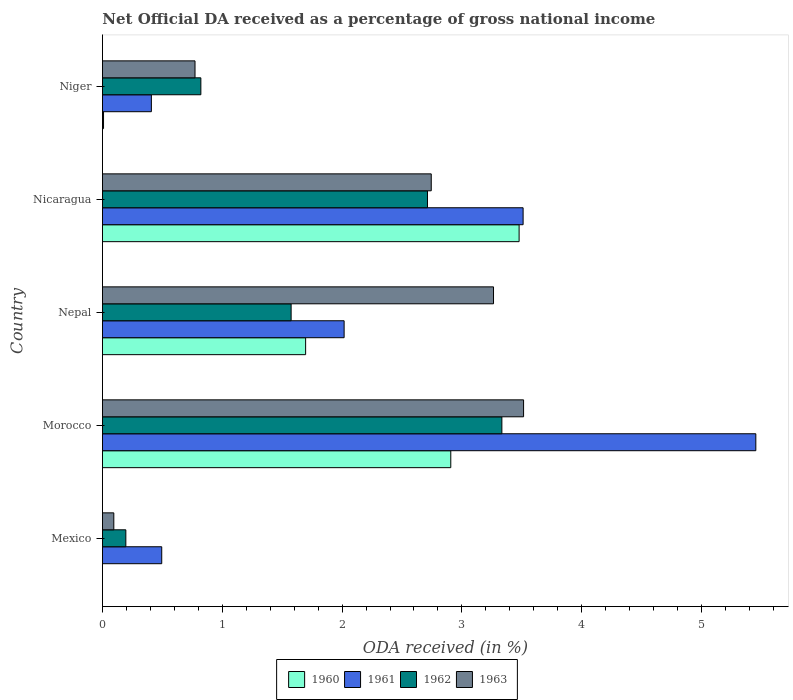How many groups of bars are there?
Give a very brief answer. 5. Are the number of bars on each tick of the Y-axis equal?
Give a very brief answer. No. What is the label of the 2nd group of bars from the top?
Keep it short and to the point. Nicaragua. In how many cases, is the number of bars for a given country not equal to the number of legend labels?
Your answer should be compact. 1. What is the net official DA received in 1962 in Nepal?
Keep it short and to the point. 1.57. Across all countries, what is the maximum net official DA received in 1960?
Keep it short and to the point. 3.48. Across all countries, what is the minimum net official DA received in 1963?
Make the answer very short. 0.09. In which country was the net official DA received in 1961 maximum?
Provide a succinct answer. Morocco. What is the total net official DA received in 1961 in the graph?
Offer a terse response. 11.88. What is the difference between the net official DA received in 1961 in Nepal and that in Nicaragua?
Provide a succinct answer. -1.49. What is the difference between the net official DA received in 1960 in Morocco and the net official DA received in 1962 in Nepal?
Offer a very short reply. 1.33. What is the average net official DA received in 1960 per country?
Your answer should be compact. 1.62. What is the difference between the net official DA received in 1963 and net official DA received in 1961 in Nepal?
Make the answer very short. 1.25. In how many countries, is the net official DA received in 1961 greater than 4.4 %?
Offer a very short reply. 1. What is the ratio of the net official DA received in 1963 in Nepal to that in Niger?
Make the answer very short. 4.23. Is the difference between the net official DA received in 1963 in Mexico and Niger greater than the difference between the net official DA received in 1961 in Mexico and Niger?
Your answer should be very brief. No. What is the difference between the highest and the second highest net official DA received in 1962?
Your response must be concise. 0.62. What is the difference between the highest and the lowest net official DA received in 1960?
Keep it short and to the point. 3.48. Are all the bars in the graph horizontal?
Ensure brevity in your answer.  Yes. How many countries are there in the graph?
Provide a short and direct response. 5. Where does the legend appear in the graph?
Your answer should be very brief. Bottom center. What is the title of the graph?
Keep it short and to the point. Net Official DA received as a percentage of gross national income. What is the label or title of the X-axis?
Offer a terse response. ODA received (in %). What is the ODA received (in %) of 1961 in Mexico?
Keep it short and to the point. 0.49. What is the ODA received (in %) in 1962 in Mexico?
Your response must be concise. 0.2. What is the ODA received (in %) of 1963 in Mexico?
Your answer should be very brief. 0.09. What is the ODA received (in %) of 1960 in Morocco?
Ensure brevity in your answer.  2.91. What is the ODA received (in %) of 1961 in Morocco?
Provide a succinct answer. 5.45. What is the ODA received (in %) of 1962 in Morocco?
Give a very brief answer. 3.33. What is the ODA received (in %) of 1963 in Morocco?
Offer a very short reply. 3.51. What is the ODA received (in %) of 1960 in Nepal?
Give a very brief answer. 1.7. What is the ODA received (in %) in 1961 in Nepal?
Provide a succinct answer. 2.02. What is the ODA received (in %) of 1962 in Nepal?
Give a very brief answer. 1.57. What is the ODA received (in %) in 1963 in Nepal?
Keep it short and to the point. 3.26. What is the ODA received (in %) in 1960 in Nicaragua?
Ensure brevity in your answer.  3.48. What is the ODA received (in %) of 1961 in Nicaragua?
Keep it short and to the point. 3.51. What is the ODA received (in %) of 1962 in Nicaragua?
Ensure brevity in your answer.  2.71. What is the ODA received (in %) in 1963 in Nicaragua?
Your answer should be very brief. 2.74. What is the ODA received (in %) of 1960 in Niger?
Your response must be concise. 0.01. What is the ODA received (in %) of 1961 in Niger?
Your answer should be compact. 0.41. What is the ODA received (in %) of 1962 in Niger?
Offer a terse response. 0.82. What is the ODA received (in %) of 1963 in Niger?
Offer a terse response. 0.77. Across all countries, what is the maximum ODA received (in %) of 1960?
Ensure brevity in your answer.  3.48. Across all countries, what is the maximum ODA received (in %) in 1961?
Your answer should be very brief. 5.45. Across all countries, what is the maximum ODA received (in %) in 1962?
Keep it short and to the point. 3.33. Across all countries, what is the maximum ODA received (in %) of 1963?
Keep it short and to the point. 3.51. Across all countries, what is the minimum ODA received (in %) in 1961?
Ensure brevity in your answer.  0.41. Across all countries, what is the minimum ODA received (in %) of 1962?
Your answer should be compact. 0.2. Across all countries, what is the minimum ODA received (in %) in 1963?
Keep it short and to the point. 0.09. What is the total ODA received (in %) of 1960 in the graph?
Provide a short and direct response. 8.09. What is the total ODA received (in %) in 1961 in the graph?
Provide a short and direct response. 11.88. What is the total ODA received (in %) of 1962 in the graph?
Your answer should be very brief. 8.64. What is the total ODA received (in %) of 1963 in the graph?
Your response must be concise. 10.39. What is the difference between the ODA received (in %) of 1961 in Mexico and that in Morocco?
Make the answer very short. -4.96. What is the difference between the ODA received (in %) of 1962 in Mexico and that in Morocco?
Ensure brevity in your answer.  -3.14. What is the difference between the ODA received (in %) in 1963 in Mexico and that in Morocco?
Your answer should be compact. -3.42. What is the difference between the ODA received (in %) of 1961 in Mexico and that in Nepal?
Your answer should be very brief. -1.52. What is the difference between the ODA received (in %) of 1962 in Mexico and that in Nepal?
Your answer should be compact. -1.38. What is the difference between the ODA received (in %) of 1963 in Mexico and that in Nepal?
Give a very brief answer. -3.17. What is the difference between the ODA received (in %) in 1961 in Mexico and that in Nicaragua?
Provide a succinct answer. -3.02. What is the difference between the ODA received (in %) in 1962 in Mexico and that in Nicaragua?
Give a very brief answer. -2.52. What is the difference between the ODA received (in %) in 1963 in Mexico and that in Nicaragua?
Your response must be concise. -2.65. What is the difference between the ODA received (in %) of 1961 in Mexico and that in Niger?
Provide a short and direct response. 0.09. What is the difference between the ODA received (in %) of 1962 in Mexico and that in Niger?
Offer a terse response. -0.63. What is the difference between the ODA received (in %) in 1963 in Mexico and that in Niger?
Provide a succinct answer. -0.68. What is the difference between the ODA received (in %) in 1960 in Morocco and that in Nepal?
Provide a short and direct response. 1.21. What is the difference between the ODA received (in %) of 1961 in Morocco and that in Nepal?
Your answer should be compact. 3.44. What is the difference between the ODA received (in %) in 1962 in Morocco and that in Nepal?
Give a very brief answer. 1.76. What is the difference between the ODA received (in %) of 1963 in Morocco and that in Nepal?
Provide a succinct answer. 0.25. What is the difference between the ODA received (in %) in 1960 in Morocco and that in Nicaragua?
Provide a succinct answer. -0.57. What is the difference between the ODA received (in %) in 1961 in Morocco and that in Nicaragua?
Offer a terse response. 1.94. What is the difference between the ODA received (in %) in 1962 in Morocco and that in Nicaragua?
Offer a terse response. 0.62. What is the difference between the ODA received (in %) of 1963 in Morocco and that in Nicaragua?
Your response must be concise. 0.77. What is the difference between the ODA received (in %) in 1960 in Morocco and that in Niger?
Your response must be concise. 2.9. What is the difference between the ODA received (in %) in 1961 in Morocco and that in Niger?
Give a very brief answer. 5.05. What is the difference between the ODA received (in %) in 1962 in Morocco and that in Niger?
Provide a succinct answer. 2.51. What is the difference between the ODA received (in %) of 1963 in Morocco and that in Niger?
Offer a very short reply. 2.74. What is the difference between the ODA received (in %) in 1960 in Nepal and that in Nicaragua?
Provide a succinct answer. -1.78. What is the difference between the ODA received (in %) in 1961 in Nepal and that in Nicaragua?
Make the answer very short. -1.49. What is the difference between the ODA received (in %) in 1962 in Nepal and that in Nicaragua?
Make the answer very short. -1.14. What is the difference between the ODA received (in %) of 1963 in Nepal and that in Nicaragua?
Make the answer very short. 0.52. What is the difference between the ODA received (in %) of 1960 in Nepal and that in Niger?
Offer a very short reply. 1.69. What is the difference between the ODA received (in %) in 1961 in Nepal and that in Niger?
Give a very brief answer. 1.61. What is the difference between the ODA received (in %) of 1962 in Nepal and that in Niger?
Offer a terse response. 0.75. What is the difference between the ODA received (in %) of 1963 in Nepal and that in Niger?
Your response must be concise. 2.49. What is the difference between the ODA received (in %) of 1960 in Nicaragua and that in Niger?
Your answer should be very brief. 3.47. What is the difference between the ODA received (in %) of 1961 in Nicaragua and that in Niger?
Provide a short and direct response. 3.1. What is the difference between the ODA received (in %) in 1962 in Nicaragua and that in Niger?
Make the answer very short. 1.89. What is the difference between the ODA received (in %) in 1963 in Nicaragua and that in Niger?
Offer a terse response. 1.97. What is the difference between the ODA received (in %) in 1961 in Mexico and the ODA received (in %) in 1962 in Morocco?
Give a very brief answer. -2.84. What is the difference between the ODA received (in %) in 1961 in Mexico and the ODA received (in %) in 1963 in Morocco?
Provide a succinct answer. -3.02. What is the difference between the ODA received (in %) in 1962 in Mexico and the ODA received (in %) in 1963 in Morocco?
Keep it short and to the point. -3.32. What is the difference between the ODA received (in %) in 1961 in Mexico and the ODA received (in %) in 1962 in Nepal?
Make the answer very short. -1.08. What is the difference between the ODA received (in %) of 1961 in Mexico and the ODA received (in %) of 1963 in Nepal?
Offer a very short reply. -2.77. What is the difference between the ODA received (in %) of 1962 in Mexico and the ODA received (in %) of 1963 in Nepal?
Offer a terse response. -3.07. What is the difference between the ODA received (in %) of 1961 in Mexico and the ODA received (in %) of 1962 in Nicaragua?
Your answer should be compact. -2.22. What is the difference between the ODA received (in %) in 1961 in Mexico and the ODA received (in %) in 1963 in Nicaragua?
Provide a short and direct response. -2.25. What is the difference between the ODA received (in %) of 1962 in Mexico and the ODA received (in %) of 1963 in Nicaragua?
Make the answer very short. -2.55. What is the difference between the ODA received (in %) in 1961 in Mexico and the ODA received (in %) in 1962 in Niger?
Your response must be concise. -0.33. What is the difference between the ODA received (in %) in 1961 in Mexico and the ODA received (in %) in 1963 in Niger?
Your answer should be compact. -0.28. What is the difference between the ODA received (in %) of 1962 in Mexico and the ODA received (in %) of 1963 in Niger?
Offer a terse response. -0.58. What is the difference between the ODA received (in %) of 1960 in Morocco and the ODA received (in %) of 1961 in Nepal?
Keep it short and to the point. 0.89. What is the difference between the ODA received (in %) of 1960 in Morocco and the ODA received (in %) of 1962 in Nepal?
Your answer should be compact. 1.33. What is the difference between the ODA received (in %) of 1960 in Morocco and the ODA received (in %) of 1963 in Nepal?
Make the answer very short. -0.36. What is the difference between the ODA received (in %) in 1961 in Morocco and the ODA received (in %) in 1962 in Nepal?
Ensure brevity in your answer.  3.88. What is the difference between the ODA received (in %) in 1961 in Morocco and the ODA received (in %) in 1963 in Nepal?
Your answer should be compact. 2.19. What is the difference between the ODA received (in %) of 1962 in Morocco and the ODA received (in %) of 1963 in Nepal?
Offer a very short reply. 0.07. What is the difference between the ODA received (in %) of 1960 in Morocco and the ODA received (in %) of 1961 in Nicaragua?
Your response must be concise. -0.6. What is the difference between the ODA received (in %) of 1960 in Morocco and the ODA received (in %) of 1962 in Nicaragua?
Your answer should be very brief. 0.19. What is the difference between the ODA received (in %) in 1960 in Morocco and the ODA received (in %) in 1963 in Nicaragua?
Offer a very short reply. 0.16. What is the difference between the ODA received (in %) of 1961 in Morocco and the ODA received (in %) of 1962 in Nicaragua?
Your response must be concise. 2.74. What is the difference between the ODA received (in %) in 1961 in Morocco and the ODA received (in %) in 1963 in Nicaragua?
Your answer should be compact. 2.71. What is the difference between the ODA received (in %) of 1962 in Morocco and the ODA received (in %) of 1963 in Nicaragua?
Provide a succinct answer. 0.59. What is the difference between the ODA received (in %) of 1960 in Morocco and the ODA received (in %) of 1961 in Niger?
Make the answer very short. 2.5. What is the difference between the ODA received (in %) in 1960 in Morocco and the ODA received (in %) in 1962 in Niger?
Ensure brevity in your answer.  2.09. What is the difference between the ODA received (in %) in 1960 in Morocco and the ODA received (in %) in 1963 in Niger?
Offer a terse response. 2.13. What is the difference between the ODA received (in %) of 1961 in Morocco and the ODA received (in %) of 1962 in Niger?
Your response must be concise. 4.63. What is the difference between the ODA received (in %) in 1961 in Morocco and the ODA received (in %) in 1963 in Niger?
Offer a very short reply. 4.68. What is the difference between the ODA received (in %) in 1962 in Morocco and the ODA received (in %) in 1963 in Niger?
Provide a short and direct response. 2.56. What is the difference between the ODA received (in %) in 1960 in Nepal and the ODA received (in %) in 1961 in Nicaragua?
Give a very brief answer. -1.82. What is the difference between the ODA received (in %) of 1960 in Nepal and the ODA received (in %) of 1962 in Nicaragua?
Provide a succinct answer. -1.02. What is the difference between the ODA received (in %) of 1960 in Nepal and the ODA received (in %) of 1963 in Nicaragua?
Provide a succinct answer. -1.05. What is the difference between the ODA received (in %) in 1961 in Nepal and the ODA received (in %) in 1962 in Nicaragua?
Your response must be concise. -0.7. What is the difference between the ODA received (in %) of 1961 in Nepal and the ODA received (in %) of 1963 in Nicaragua?
Offer a terse response. -0.73. What is the difference between the ODA received (in %) of 1962 in Nepal and the ODA received (in %) of 1963 in Nicaragua?
Give a very brief answer. -1.17. What is the difference between the ODA received (in %) in 1960 in Nepal and the ODA received (in %) in 1961 in Niger?
Give a very brief answer. 1.29. What is the difference between the ODA received (in %) of 1960 in Nepal and the ODA received (in %) of 1962 in Niger?
Keep it short and to the point. 0.87. What is the difference between the ODA received (in %) in 1960 in Nepal and the ODA received (in %) in 1963 in Niger?
Give a very brief answer. 0.92. What is the difference between the ODA received (in %) in 1961 in Nepal and the ODA received (in %) in 1962 in Niger?
Give a very brief answer. 1.2. What is the difference between the ODA received (in %) of 1961 in Nepal and the ODA received (in %) of 1963 in Niger?
Your answer should be compact. 1.24. What is the difference between the ODA received (in %) in 1962 in Nepal and the ODA received (in %) in 1963 in Niger?
Provide a short and direct response. 0.8. What is the difference between the ODA received (in %) in 1960 in Nicaragua and the ODA received (in %) in 1961 in Niger?
Ensure brevity in your answer.  3.07. What is the difference between the ODA received (in %) of 1960 in Nicaragua and the ODA received (in %) of 1962 in Niger?
Provide a succinct answer. 2.66. What is the difference between the ODA received (in %) of 1960 in Nicaragua and the ODA received (in %) of 1963 in Niger?
Provide a short and direct response. 2.71. What is the difference between the ODA received (in %) of 1961 in Nicaragua and the ODA received (in %) of 1962 in Niger?
Keep it short and to the point. 2.69. What is the difference between the ODA received (in %) of 1961 in Nicaragua and the ODA received (in %) of 1963 in Niger?
Provide a succinct answer. 2.74. What is the difference between the ODA received (in %) of 1962 in Nicaragua and the ODA received (in %) of 1963 in Niger?
Offer a very short reply. 1.94. What is the average ODA received (in %) in 1960 per country?
Your response must be concise. 1.62. What is the average ODA received (in %) of 1961 per country?
Provide a short and direct response. 2.38. What is the average ODA received (in %) in 1962 per country?
Your answer should be compact. 1.73. What is the average ODA received (in %) of 1963 per country?
Provide a succinct answer. 2.08. What is the difference between the ODA received (in %) in 1961 and ODA received (in %) in 1962 in Mexico?
Provide a short and direct response. 0.3. What is the difference between the ODA received (in %) in 1962 and ODA received (in %) in 1963 in Mexico?
Make the answer very short. 0.1. What is the difference between the ODA received (in %) of 1960 and ODA received (in %) of 1961 in Morocco?
Offer a very short reply. -2.55. What is the difference between the ODA received (in %) of 1960 and ODA received (in %) of 1962 in Morocco?
Ensure brevity in your answer.  -0.43. What is the difference between the ODA received (in %) of 1960 and ODA received (in %) of 1963 in Morocco?
Your answer should be very brief. -0.61. What is the difference between the ODA received (in %) of 1961 and ODA received (in %) of 1962 in Morocco?
Make the answer very short. 2.12. What is the difference between the ODA received (in %) in 1961 and ODA received (in %) in 1963 in Morocco?
Offer a very short reply. 1.94. What is the difference between the ODA received (in %) of 1962 and ODA received (in %) of 1963 in Morocco?
Your answer should be very brief. -0.18. What is the difference between the ODA received (in %) in 1960 and ODA received (in %) in 1961 in Nepal?
Make the answer very short. -0.32. What is the difference between the ODA received (in %) of 1960 and ODA received (in %) of 1962 in Nepal?
Give a very brief answer. 0.12. What is the difference between the ODA received (in %) in 1960 and ODA received (in %) in 1963 in Nepal?
Keep it short and to the point. -1.57. What is the difference between the ODA received (in %) in 1961 and ODA received (in %) in 1962 in Nepal?
Ensure brevity in your answer.  0.44. What is the difference between the ODA received (in %) in 1961 and ODA received (in %) in 1963 in Nepal?
Offer a very short reply. -1.25. What is the difference between the ODA received (in %) in 1962 and ODA received (in %) in 1963 in Nepal?
Give a very brief answer. -1.69. What is the difference between the ODA received (in %) of 1960 and ODA received (in %) of 1961 in Nicaragua?
Provide a succinct answer. -0.03. What is the difference between the ODA received (in %) in 1960 and ODA received (in %) in 1962 in Nicaragua?
Provide a succinct answer. 0.76. What is the difference between the ODA received (in %) in 1960 and ODA received (in %) in 1963 in Nicaragua?
Your response must be concise. 0.73. What is the difference between the ODA received (in %) of 1961 and ODA received (in %) of 1962 in Nicaragua?
Provide a short and direct response. 0.8. What is the difference between the ODA received (in %) of 1961 and ODA received (in %) of 1963 in Nicaragua?
Provide a short and direct response. 0.77. What is the difference between the ODA received (in %) in 1962 and ODA received (in %) in 1963 in Nicaragua?
Your answer should be compact. -0.03. What is the difference between the ODA received (in %) of 1960 and ODA received (in %) of 1961 in Niger?
Your response must be concise. -0.4. What is the difference between the ODA received (in %) in 1960 and ODA received (in %) in 1962 in Niger?
Give a very brief answer. -0.81. What is the difference between the ODA received (in %) in 1960 and ODA received (in %) in 1963 in Niger?
Provide a succinct answer. -0.76. What is the difference between the ODA received (in %) in 1961 and ODA received (in %) in 1962 in Niger?
Your answer should be compact. -0.41. What is the difference between the ODA received (in %) of 1961 and ODA received (in %) of 1963 in Niger?
Your answer should be very brief. -0.36. What is the difference between the ODA received (in %) of 1962 and ODA received (in %) of 1963 in Niger?
Your answer should be very brief. 0.05. What is the ratio of the ODA received (in %) of 1961 in Mexico to that in Morocco?
Keep it short and to the point. 0.09. What is the ratio of the ODA received (in %) in 1962 in Mexico to that in Morocco?
Your answer should be very brief. 0.06. What is the ratio of the ODA received (in %) of 1963 in Mexico to that in Morocco?
Keep it short and to the point. 0.03. What is the ratio of the ODA received (in %) of 1961 in Mexico to that in Nepal?
Provide a succinct answer. 0.25. What is the ratio of the ODA received (in %) of 1962 in Mexico to that in Nepal?
Your answer should be compact. 0.12. What is the ratio of the ODA received (in %) of 1963 in Mexico to that in Nepal?
Your answer should be very brief. 0.03. What is the ratio of the ODA received (in %) in 1961 in Mexico to that in Nicaragua?
Ensure brevity in your answer.  0.14. What is the ratio of the ODA received (in %) of 1962 in Mexico to that in Nicaragua?
Make the answer very short. 0.07. What is the ratio of the ODA received (in %) of 1963 in Mexico to that in Nicaragua?
Your answer should be very brief. 0.03. What is the ratio of the ODA received (in %) in 1961 in Mexico to that in Niger?
Your answer should be very brief. 1.21. What is the ratio of the ODA received (in %) of 1962 in Mexico to that in Niger?
Offer a terse response. 0.24. What is the ratio of the ODA received (in %) of 1963 in Mexico to that in Niger?
Offer a very short reply. 0.12. What is the ratio of the ODA received (in %) in 1960 in Morocco to that in Nepal?
Your response must be concise. 1.71. What is the ratio of the ODA received (in %) of 1961 in Morocco to that in Nepal?
Your answer should be compact. 2.7. What is the ratio of the ODA received (in %) of 1962 in Morocco to that in Nepal?
Make the answer very short. 2.12. What is the ratio of the ODA received (in %) in 1963 in Morocco to that in Nepal?
Provide a short and direct response. 1.08. What is the ratio of the ODA received (in %) in 1960 in Morocco to that in Nicaragua?
Give a very brief answer. 0.84. What is the ratio of the ODA received (in %) of 1961 in Morocco to that in Nicaragua?
Ensure brevity in your answer.  1.55. What is the ratio of the ODA received (in %) of 1962 in Morocco to that in Nicaragua?
Offer a terse response. 1.23. What is the ratio of the ODA received (in %) of 1963 in Morocco to that in Nicaragua?
Ensure brevity in your answer.  1.28. What is the ratio of the ODA received (in %) of 1960 in Morocco to that in Niger?
Give a very brief answer. 327.61. What is the ratio of the ODA received (in %) in 1961 in Morocco to that in Niger?
Your answer should be very brief. 13.36. What is the ratio of the ODA received (in %) in 1962 in Morocco to that in Niger?
Keep it short and to the point. 4.06. What is the ratio of the ODA received (in %) in 1963 in Morocco to that in Niger?
Make the answer very short. 4.55. What is the ratio of the ODA received (in %) in 1960 in Nepal to that in Nicaragua?
Give a very brief answer. 0.49. What is the ratio of the ODA received (in %) of 1961 in Nepal to that in Nicaragua?
Provide a succinct answer. 0.57. What is the ratio of the ODA received (in %) in 1962 in Nepal to that in Nicaragua?
Make the answer very short. 0.58. What is the ratio of the ODA received (in %) in 1963 in Nepal to that in Nicaragua?
Your response must be concise. 1.19. What is the ratio of the ODA received (in %) of 1960 in Nepal to that in Niger?
Offer a terse response. 191.09. What is the ratio of the ODA received (in %) of 1961 in Nepal to that in Niger?
Your answer should be compact. 4.94. What is the ratio of the ODA received (in %) of 1962 in Nepal to that in Niger?
Provide a succinct answer. 1.92. What is the ratio of the ODA received (in %) of 1963 in Nepal to that in Niger?
Your answer should be very brief. 4.23. What is the ratio of the ODA received (in %) of 1960 in Nicaragua to that in Niger?
Offer a terse response. 391.87. What is the ratio of the ODA received (in %) of 1961 in Nicaragua to that in Niger?
Offer a very short reply. 8.6. What is the ratio of the ODA received (in %) in 1962 in Nicaragua to that in Niger?
Keep it short and to the point. 3.3. What is the ratio of the ODA received (in %) of 1963 in Nicaragua to that in Niger?
Give a very brief answer. 3.55. What is the difference between the highest and the second highest ODA received (in %) of 1960?
Your response must be concise. 0.57. What is the difference between the highest and the second highest ODA received (in %) in 1961?
Your response must be concise. 1.94. What is the difference between the highest and the second highest ODA received (in %) in 1962?
Your answer should be compact. 0.62. What is the difference between the highest and the second highest ODA received (in %) in 1963?
Offer a very short reply. 0.25. What is the difference between the highest and the lowest ODA received (in %) of 1960?
Your answer should be compact. 3.48. What is the difference between the highest and the lowest ODA received (in %) of 1961?
Ensure brevity in your answer.  5.05. What is the difference between the highest and the lowest ODA received (in %) of 1962?
Provide a short and direct response. 3.14. What is the difference between the highest and the lowest ODA received (in %) in 1963?
Provide a succinct answer. 3.42. 